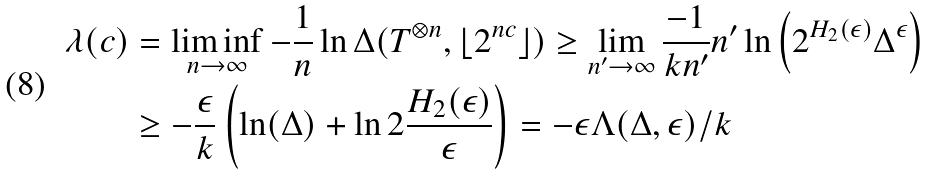Convert formula to latex. <formula><loc_0><loc_0><loc_500><loc_500>\lambda ( c ) & = \liminf _ { n \to \infty } - \frac { 1 } { n } \ln \Delta ( T ^ { \otimes n } , \lfloor 2 ^ { n c } \rfloor ) \geq \lim _ { n ^ { \prime } \to \infty } \frac { - 1 } { k n ^ { \prime } } n ^ { \prime } \ln \left ( 2 ^ { H _ { 2 } ( \epsilon ) } \Delta ^ { \epsilon } \right ) \\ & \geq - \frac { \epsilon } { k } \left ( \ln ( \Delta ) + \ln 2 \frac { H _ { 2 } ( \epsilon ) } { \epsilon } \right ) = - \epsilon \Lambda ( \Delta , \epsilon ) / k</formula> 